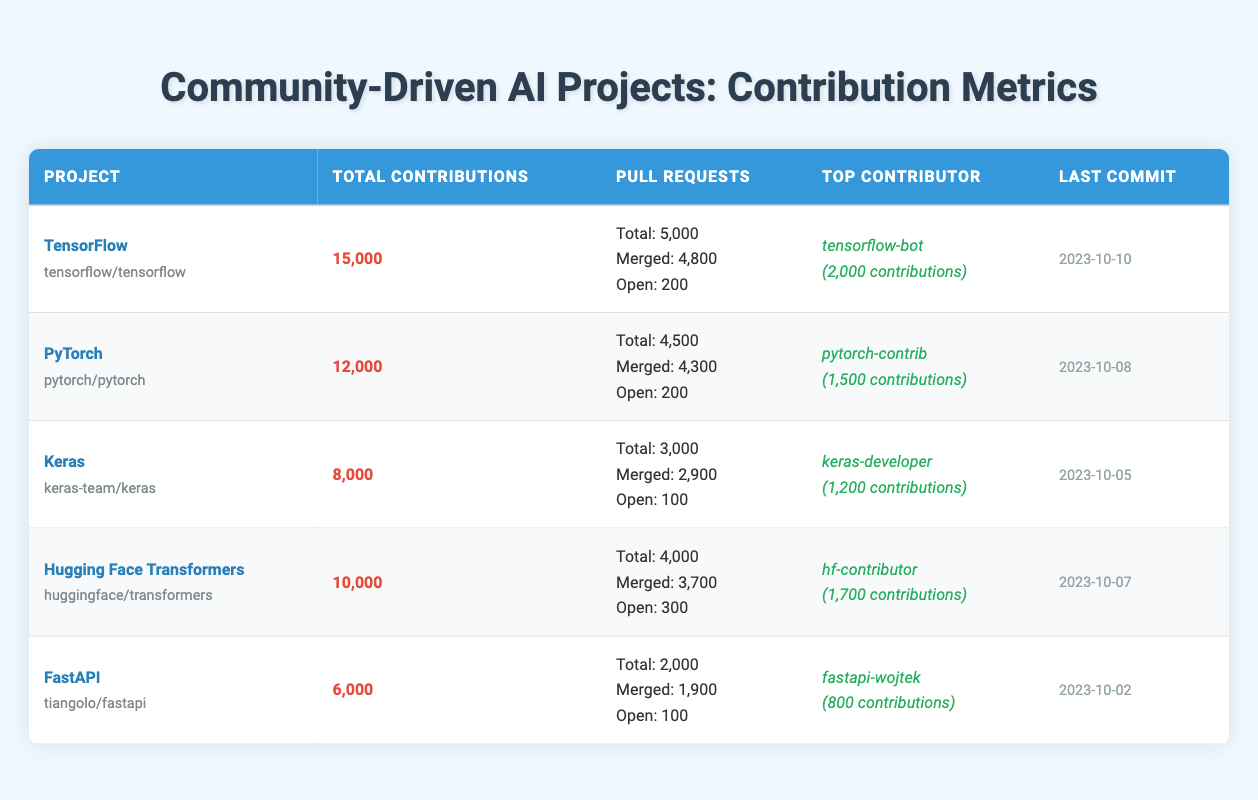What is the total number of contributions for TensorFlow? The table indicates that TensorFlow has a total of 15,000 contributions listed under the "Total Contributions" column.
Answer: 15,000 How many merged pull requests does PyTorch have? Looking at the "Merged" row under the "Pull Requests" column for PyTorch, it states that there are 4,300 merged pull requests.
Answer: 4,300 Is Keras the project with the highest total contributions? By comparing the "Total Contributions" of all listed projects, Keras has 8,000 contributions, which is less than TensorFlow (15,000) and PyTorch (12,000). Therefore, Keras is not the project with the highest contributions.
Answer: No Which project has the most open pull requests? The table shows that Hugging Face Transformers has 300 open pull requests, which is the highest among all projects listed (FastAPI has 100, Keras has 100, and TensorFlow and PyTorch each have 200).
Answer: Hugging Face Transformers What is the difference in total contributions between FastAPI and Keras? FastAPI has 6,000 total contributions and Keras has 8,000. The difference is calculated as 8,000 - 6,000 = 2,000.
Answer: 2,000 Who is the top contributor for Hugging Face Transformers? The table specifies that the top contributor for Hugging Face Transformers is "hf-contributor" with 1,700 contributions.
Answer: hf-contributor What is the average number of total contributions across all projects? To find the average, sum all total contributions (15,000 + 12,000 + 8,000 + 10,000 + 6,000 = 51,000) and divide by the number of projects (5). Thus, the average is 51,000 / 5 = 10,200.
Answer: 10,200 Which project had the last commit date? The last commit date in the table is for TensorFlow, which is listed as 2023-10-10, indicating it is the most recent commit among all projects presented.
Answer: TensorFlow How many total pull requests does Keras have? Keras is recorded in the table with a total number of pull requests as 3,000 under the "Pull Requests" column.
Answer: 3,000 